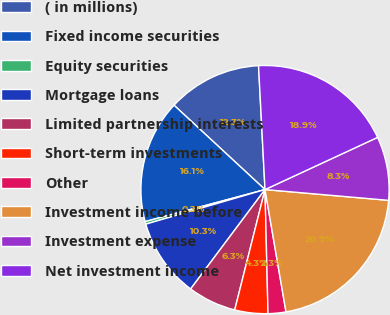Convert chart. <chart><loc_0><loc_0><loc_500><loc_500><pie_chart><fcel>( in millions)<fcel>Fixed income securities<fcel>Equity securities<fcel>Mortgage loans<fcel>Limited partnership interests<fcel>Short-term investments<fcel>Other<fcel>Investment income before<fcel>Investment expense<fcel>Net investment income<nl><fcel>12.27%<fcel>16.05%<fcel>0.34%<fcel>10.28%<fcel>6.3%<fcel>4.31%<fcel>2.32%<fcel>20.91%<fcel>8.29%<fcel>18.92%<nl></chart> 